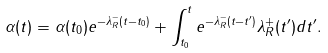Convert formula to latex. <formula><loc_0><loc_0><loc_500><loc_500>\alpha ( t ) = \alpha ( t _ { 0 } ) e ^ { - \lambda _ { R } ^ { - } ( t - t _ { 0 } ) } + \int _ { t _ { 0 } } ^ { t } e ^ { - \lambda _ { R } ^ { - } ( t - t ^ { \prime } ) } \lambda _ { R } ^ { + } ( t ^ { \prime } ) d t ^ { \prime } .</formula> 